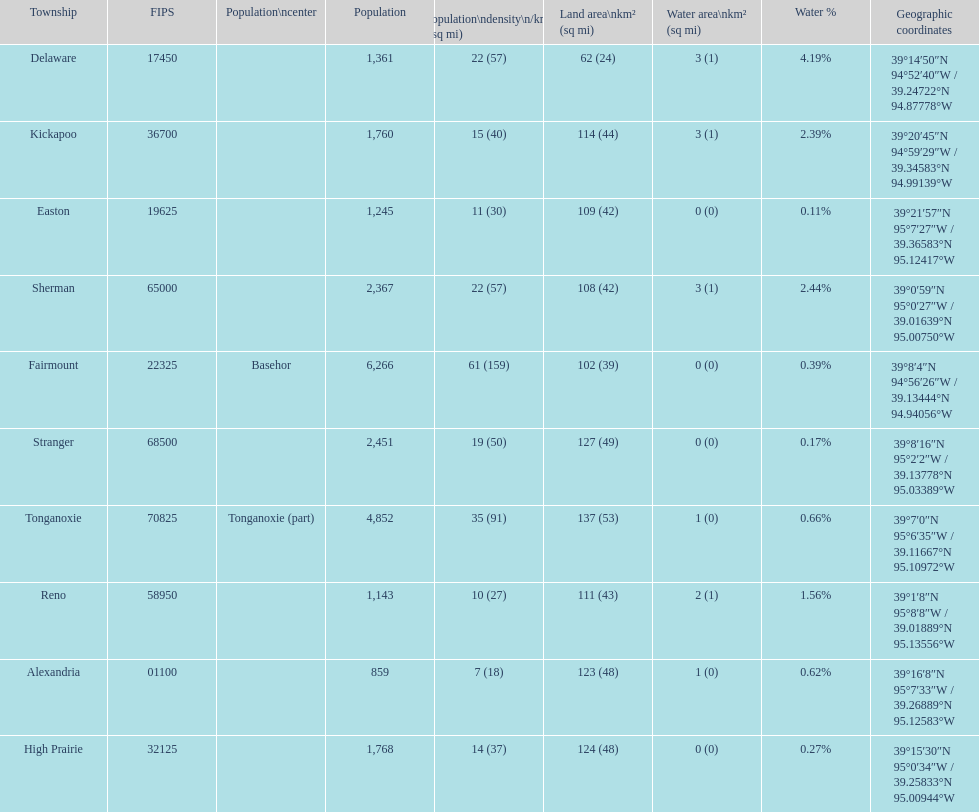How many townships are in leavenworth county? 10. 